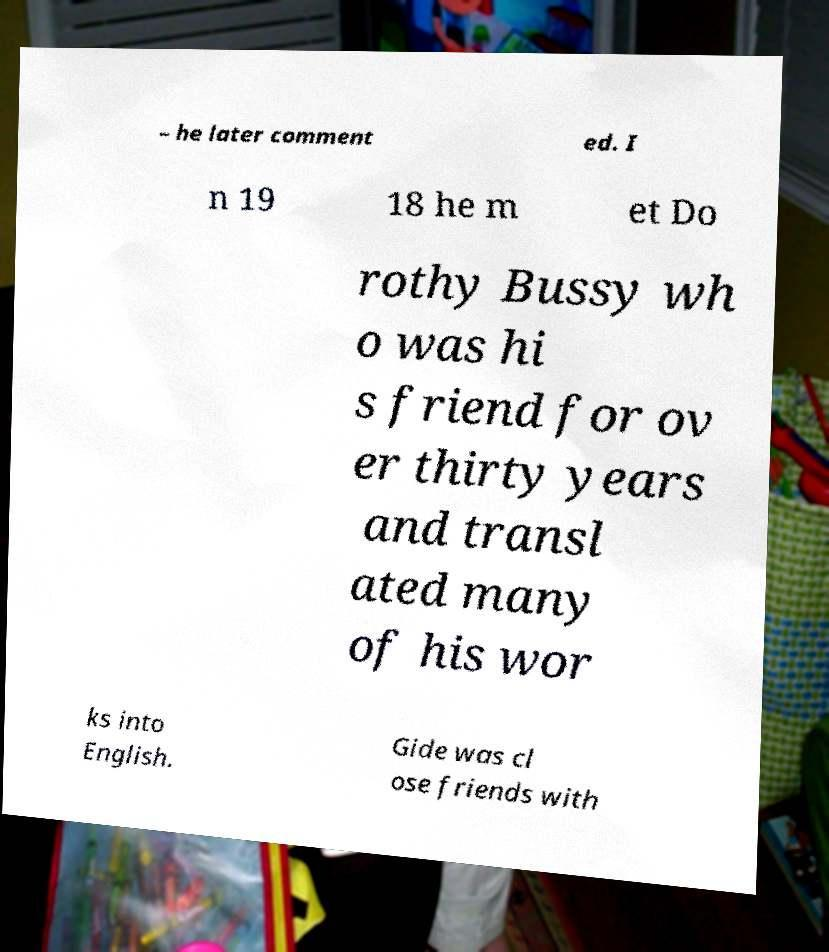I need the written content from this picture converted into text. Can you do that? – he later comment ed. I n 19 18 he m et Do rothy Bussy wh o was hi s friend for ov er thirty years and transl ated many of his wor ks into English. Gide was cl ose friends with 